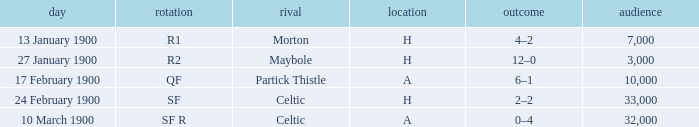How many people attended in the game against morton? 7000.0. 